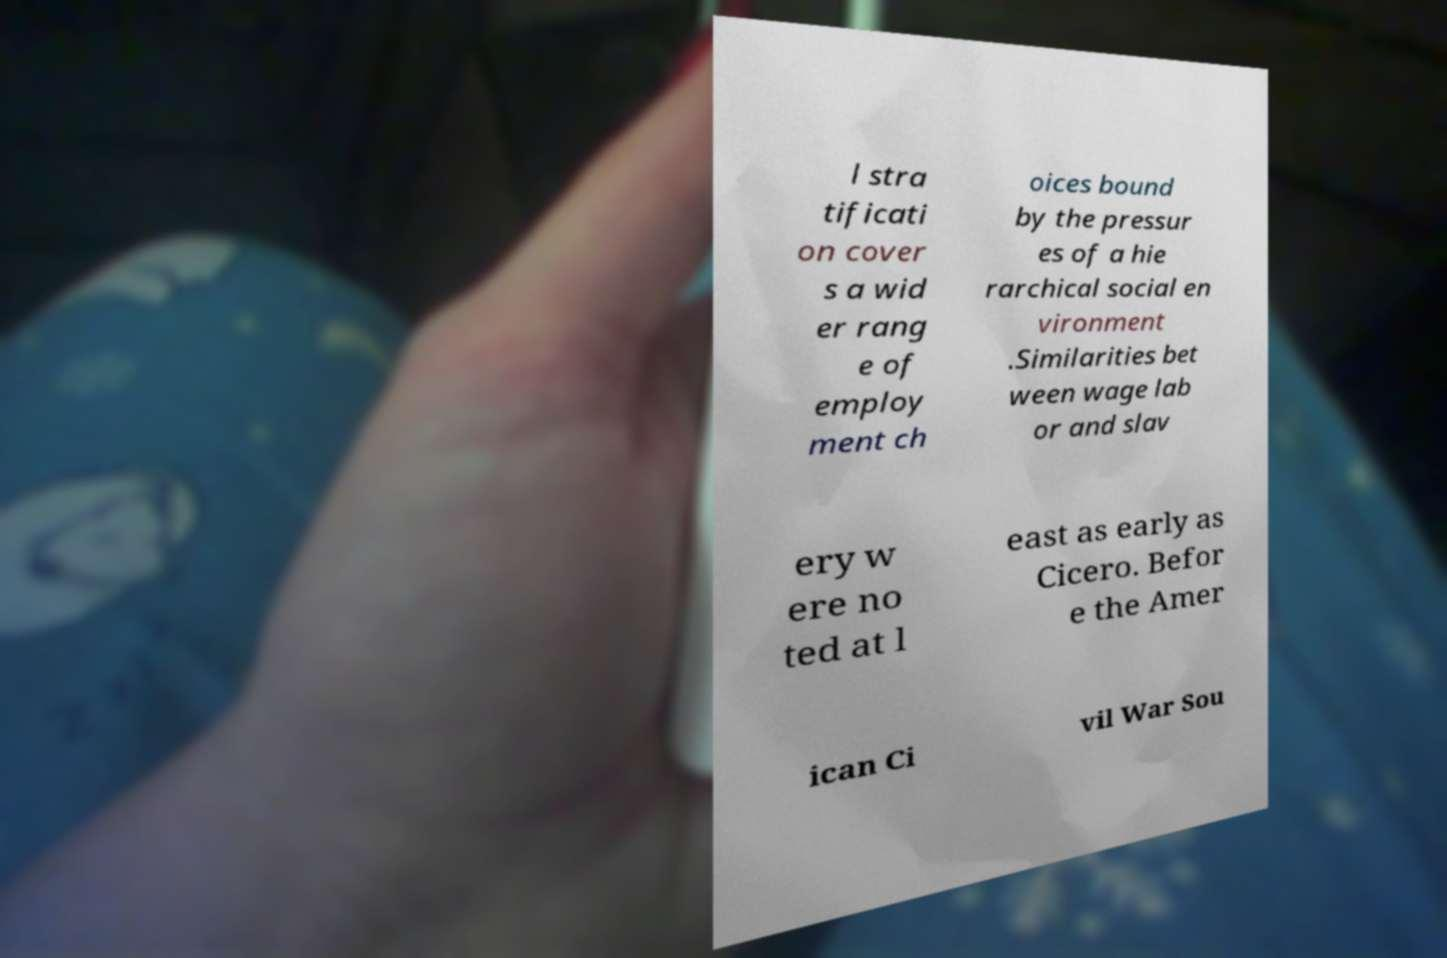Can you accurately transcribe the text from the provided image for me? l stra tificati on cover s a wid er rang e of employ ment ch oices bound by the pressur es of a hie rarchical social en vironment .Similarities bet ween wage lab or and slav ery w ere no ted at l east as early as Cicero. Befor e the Amer ican Ci vil War Sou 